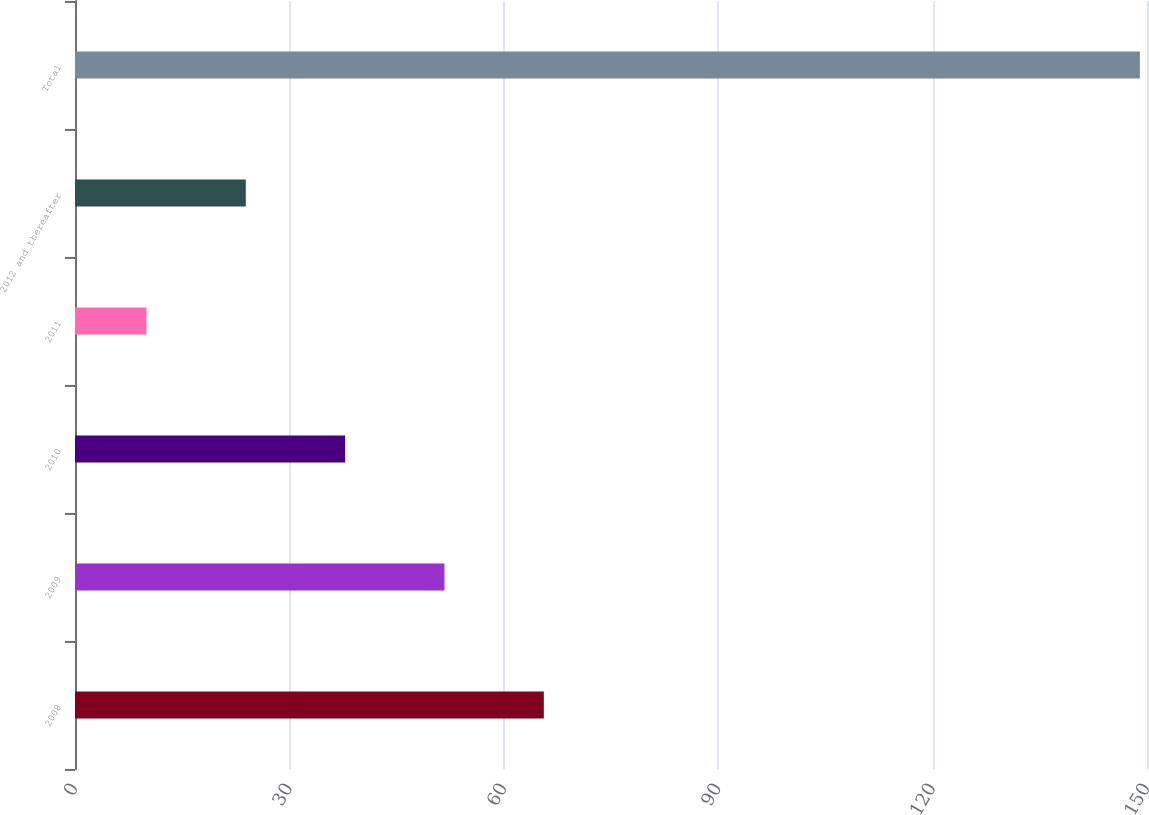<chart> <loc_0><loc_0><loc_500><loc_500><bar_chart><fcel>2008<fcel>2009<fcel>2010<fcel>2011<fcel>2012 and thereafter<fcel>Total<nl><fcel>65.6<fcel>51.7<fcel>37.8<fcel>10<fcel>23.9<fcel>149<nl></chart> 